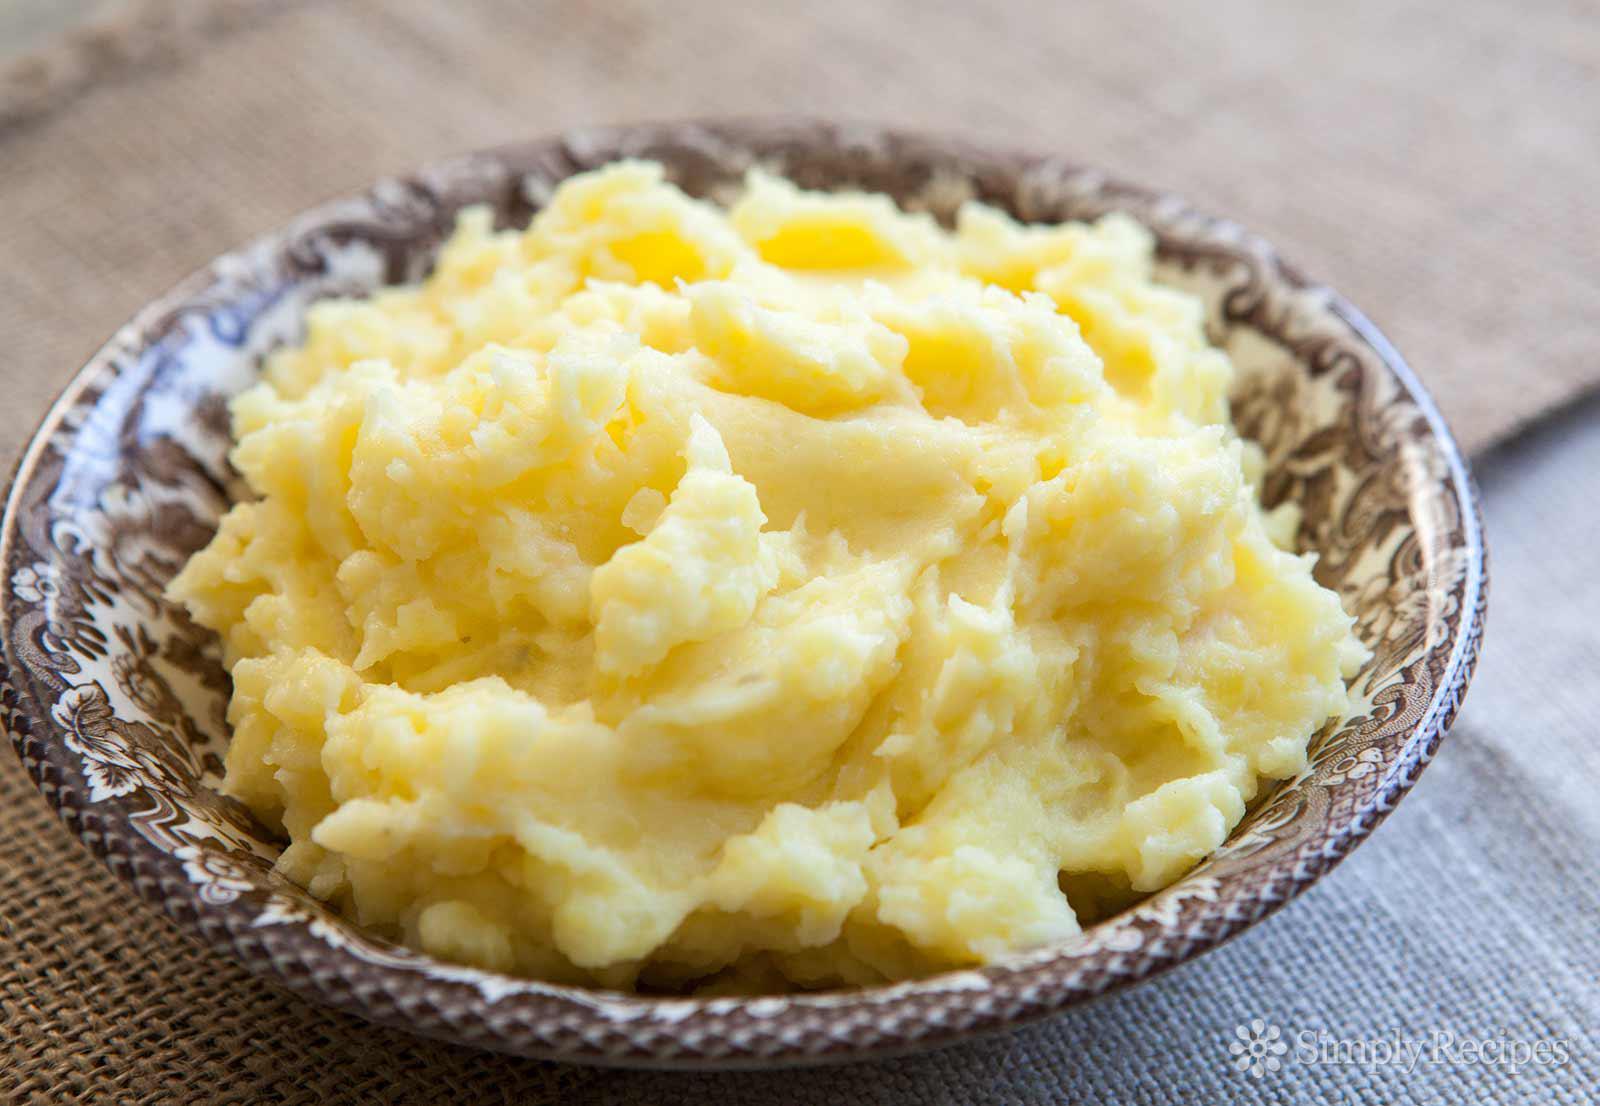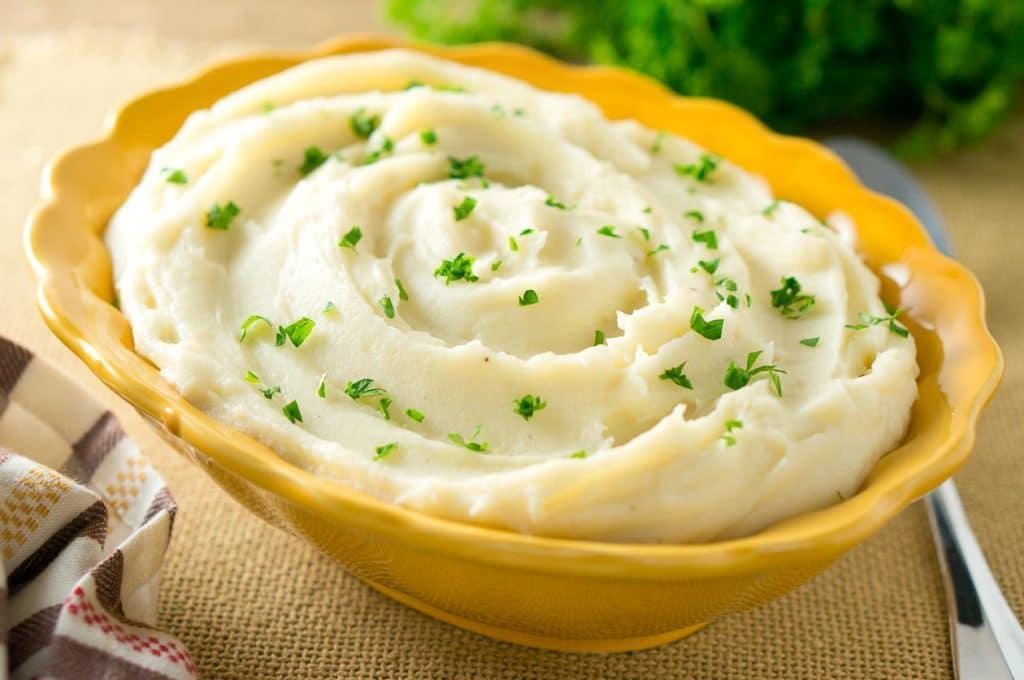The first image is the image on the left, the second image is the image on the right. For the images shown, is this caption "There is a utensil in the food in the image on the left." true? Answer yes or no. No. 